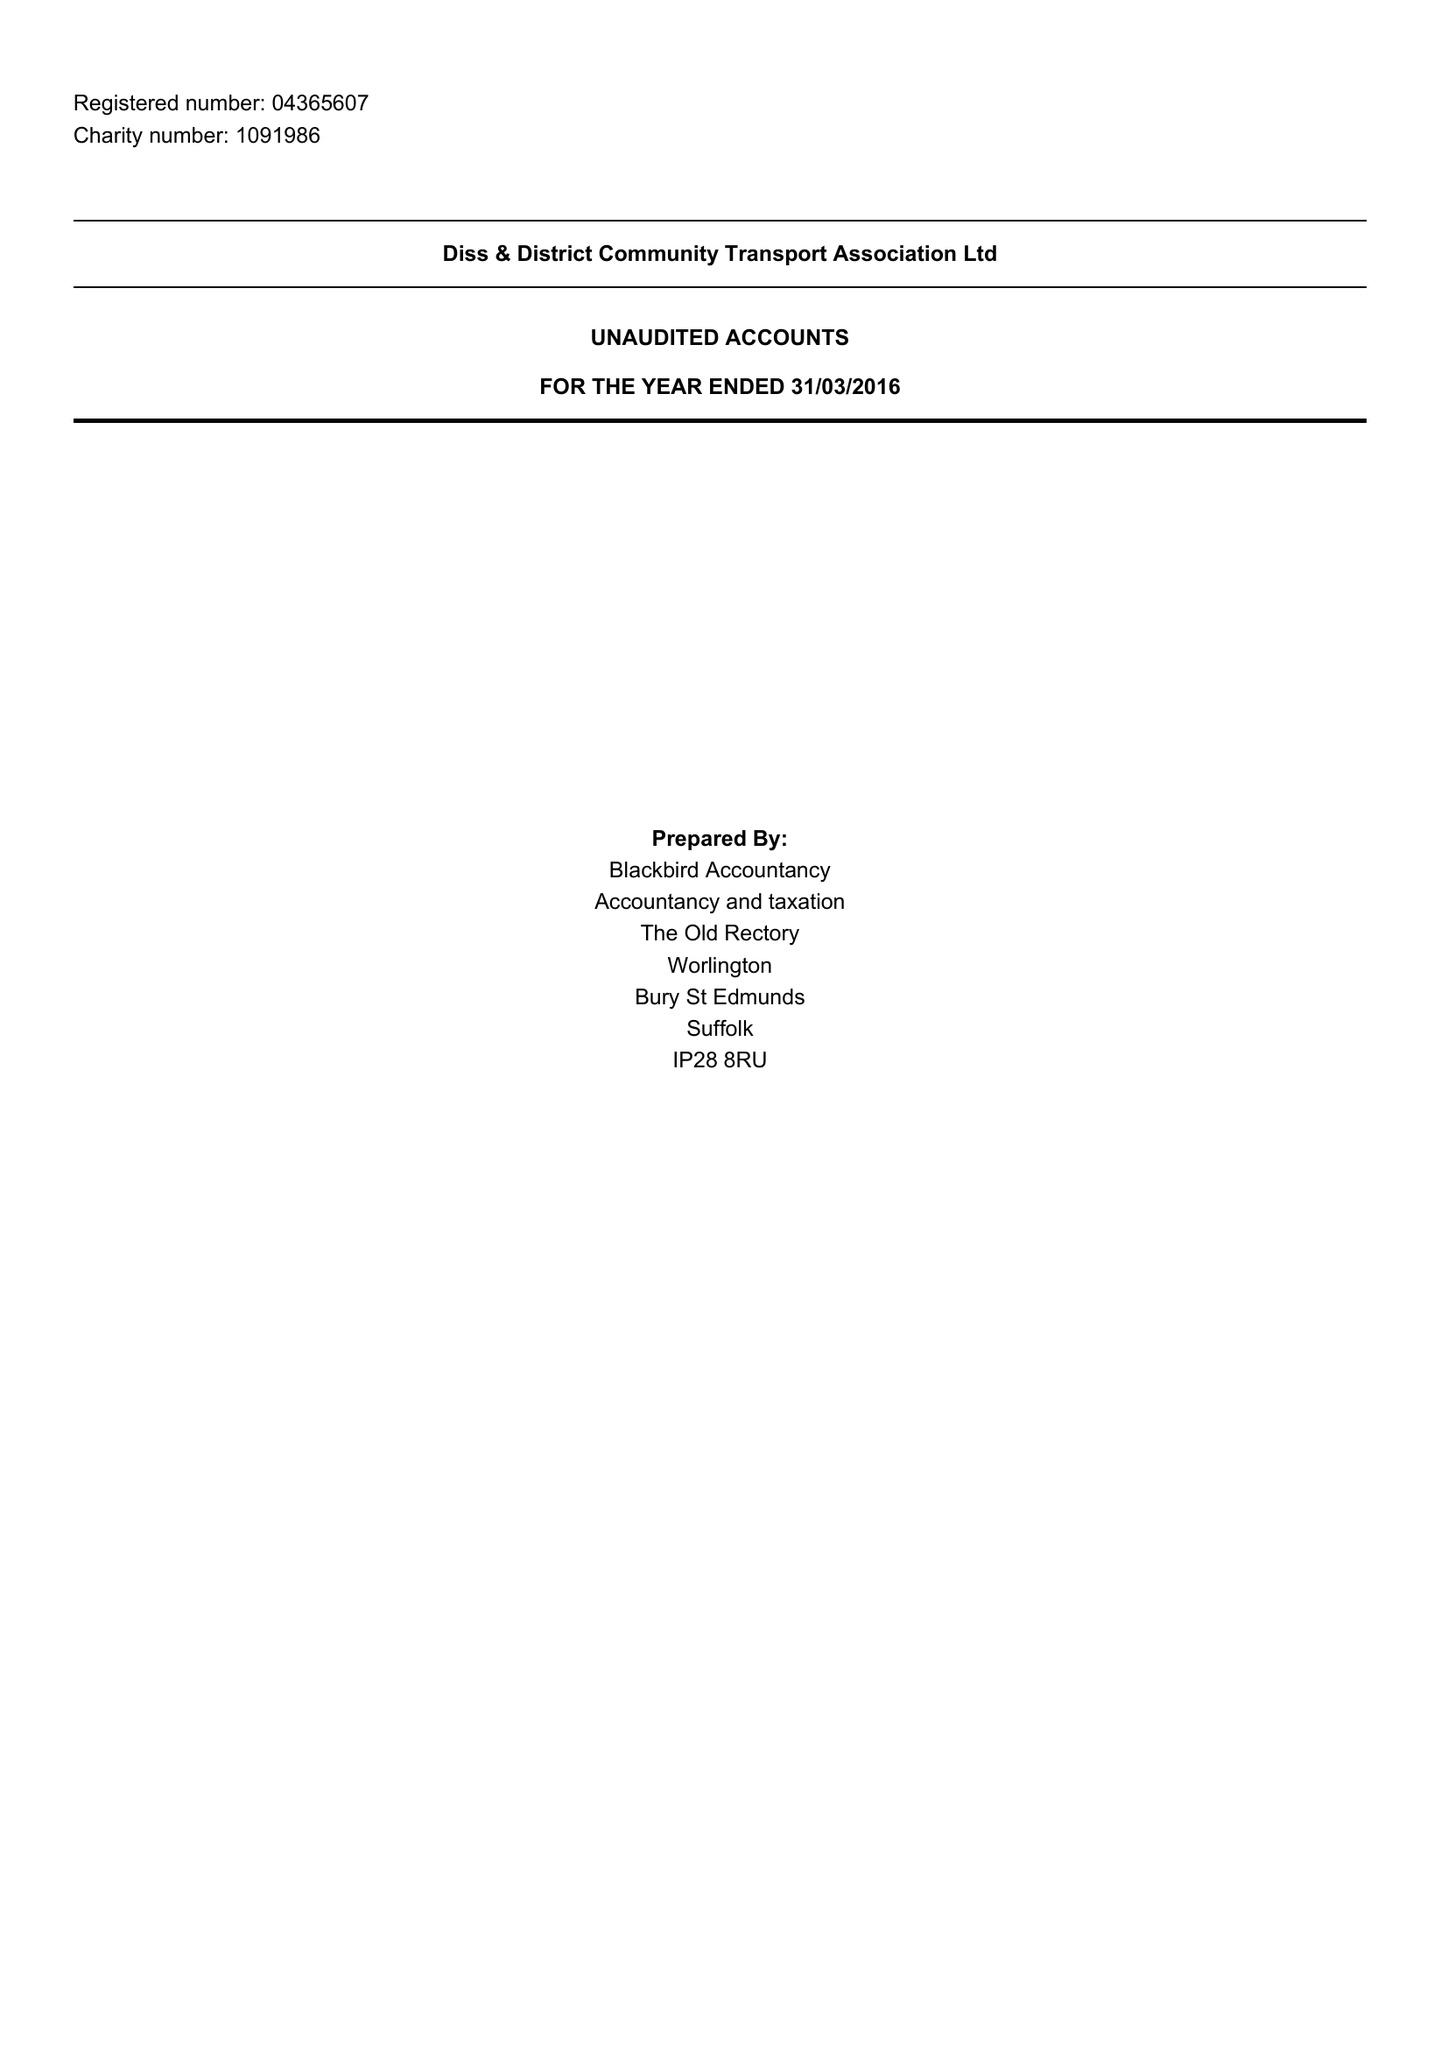What is the value for the address__street_line?
Answer the question using a single word or phrase. THE STREET 